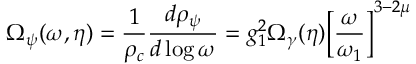<formula> <loc_0><loc_0><loc_500><loc_500>\Omega _ { \psi } ( \omega , \eta ) = \frac { 1 } { \rho _ { c } } \frac { d \rho _ { \psi } } { d \log { \omega } } = g _ { 1 } ^ { 2 } \Omega _ { \gamma } ( \eta ) \left [ \frac { \omega } { \omega _ { 1 } } \right ] ^ { 3 - 2 \mu }</formula> 